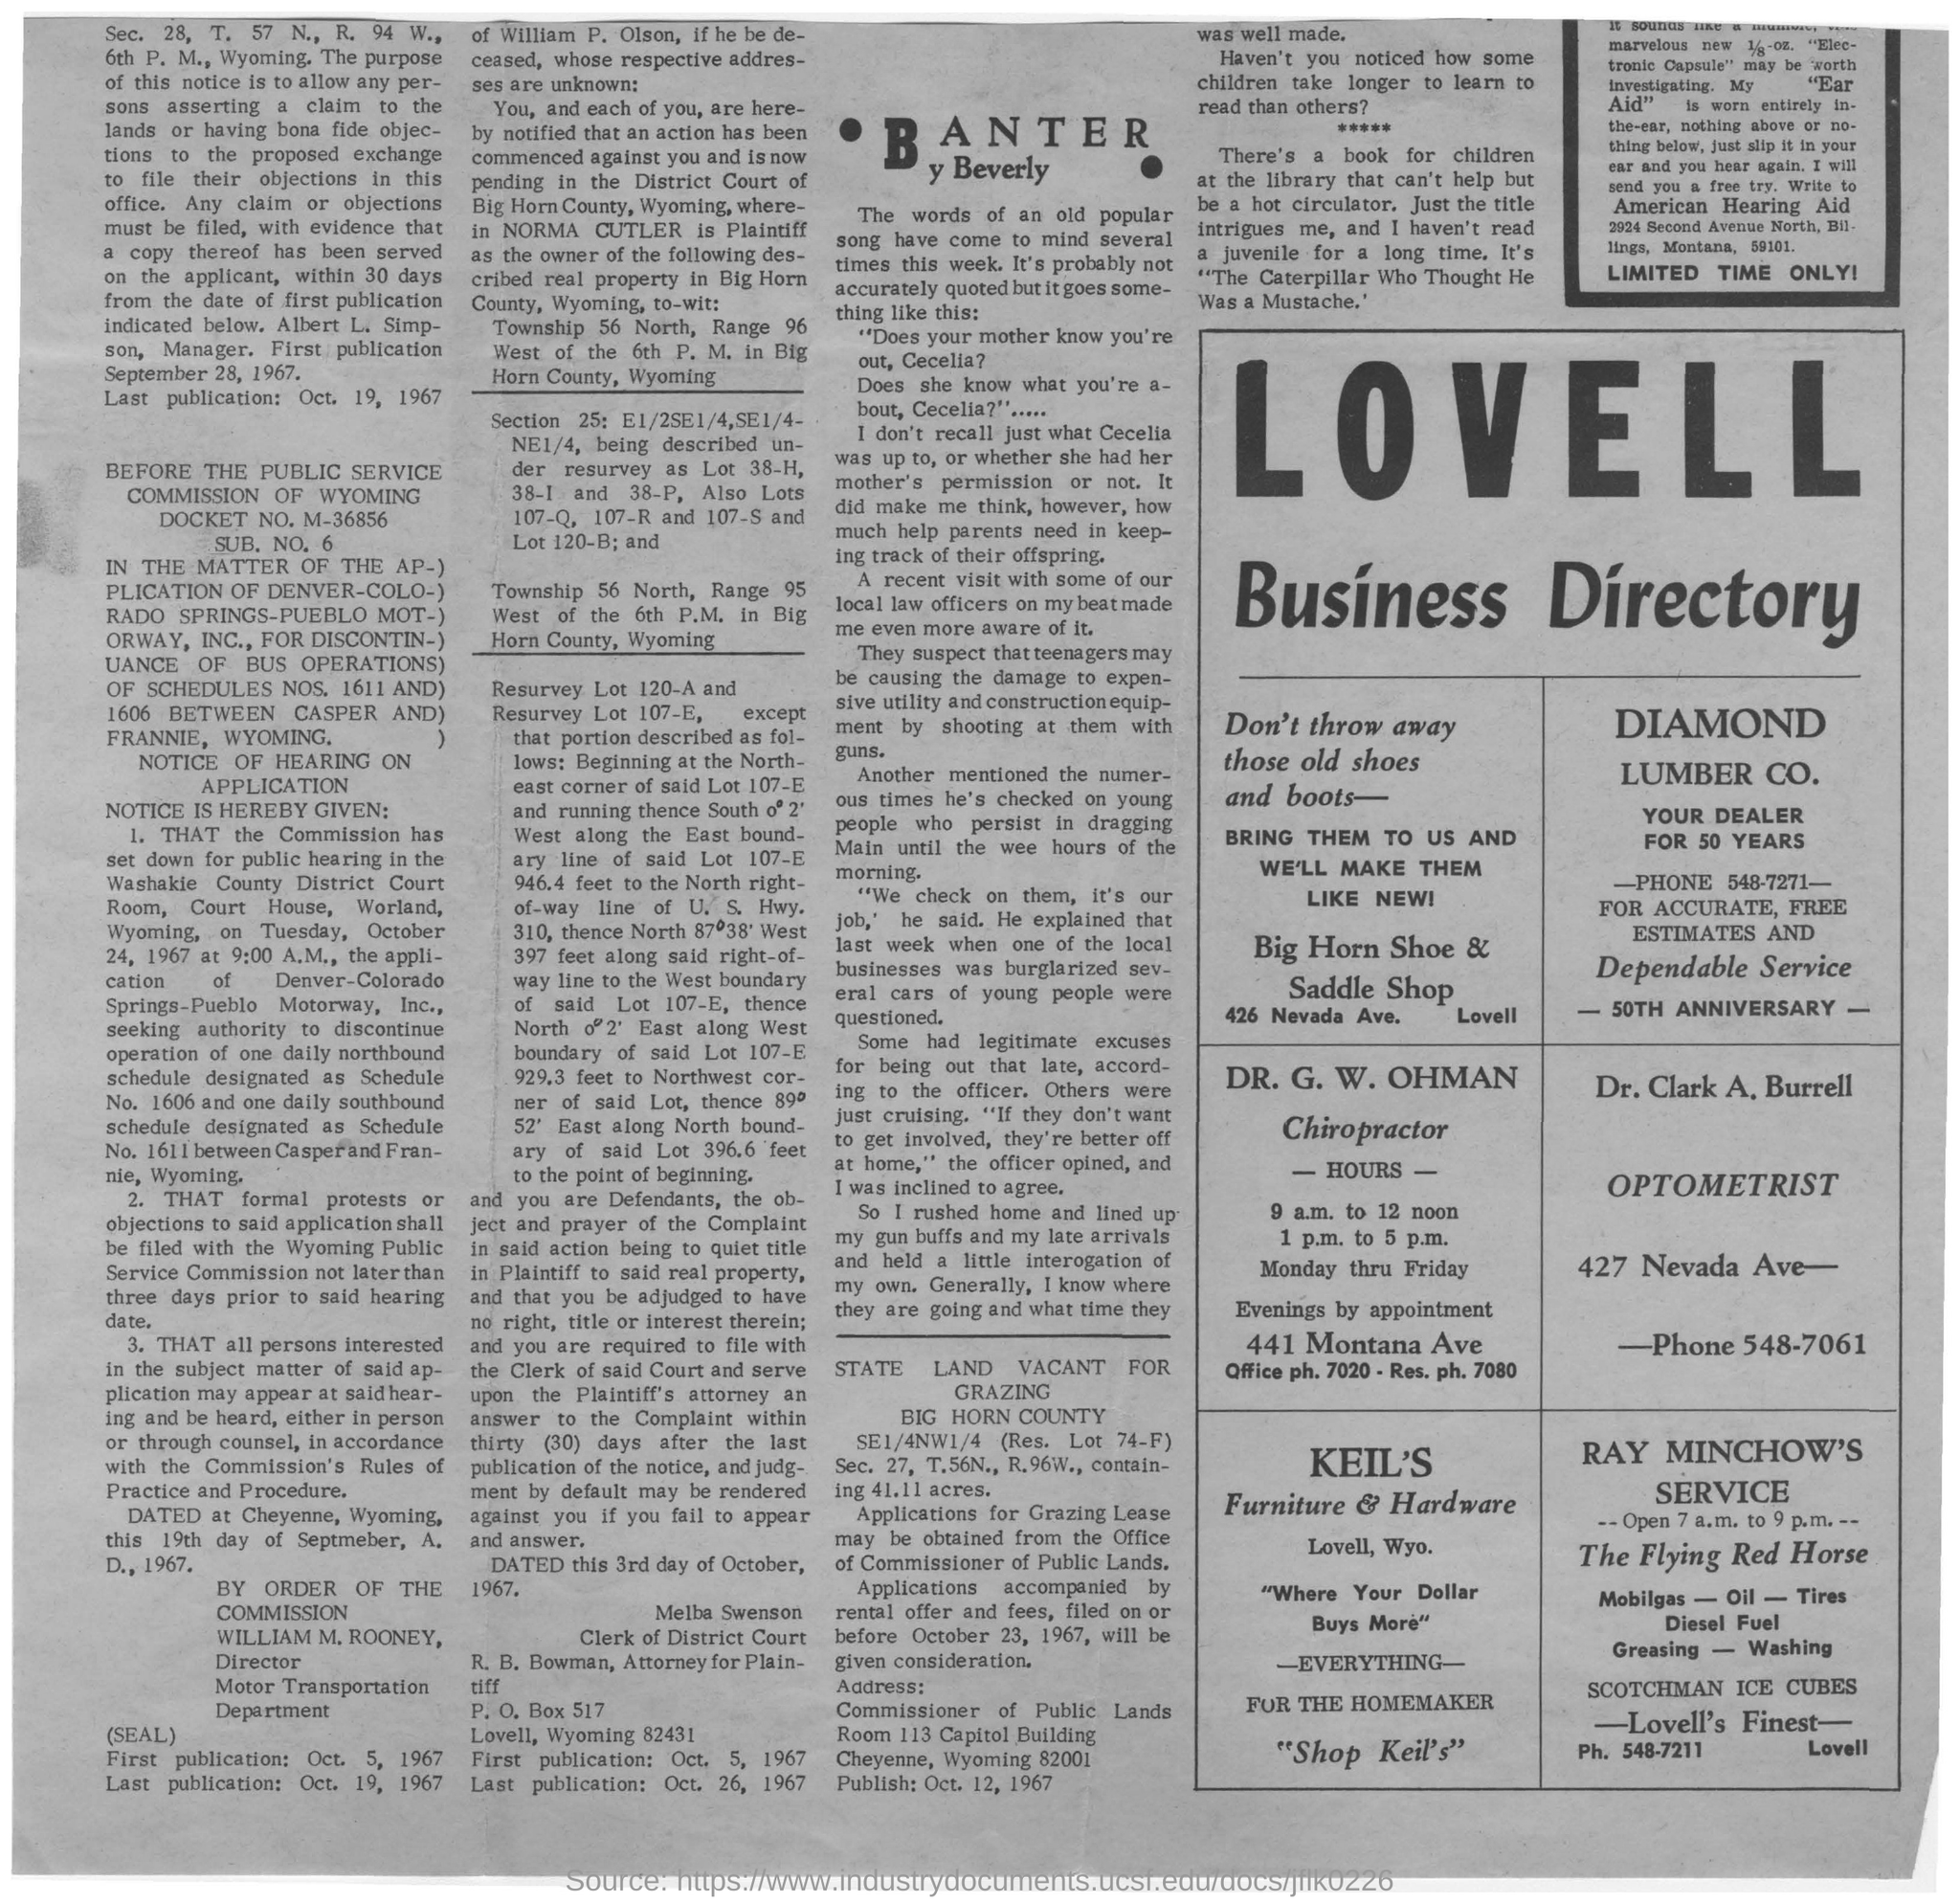What is the Business Directory's name?
Offer a terse response. Lovell. What is the name of the Furniture & Hardware company?
Keep it short and to the point. Keil's. From when to when is RAY MINCHOW'S SERVICE open?
Provide a succinct answer. 7 a.m. to 9 p.m. Who is the OPTOMETRIST?
Offer a terse response. Dr. Clark A. Burrell. 